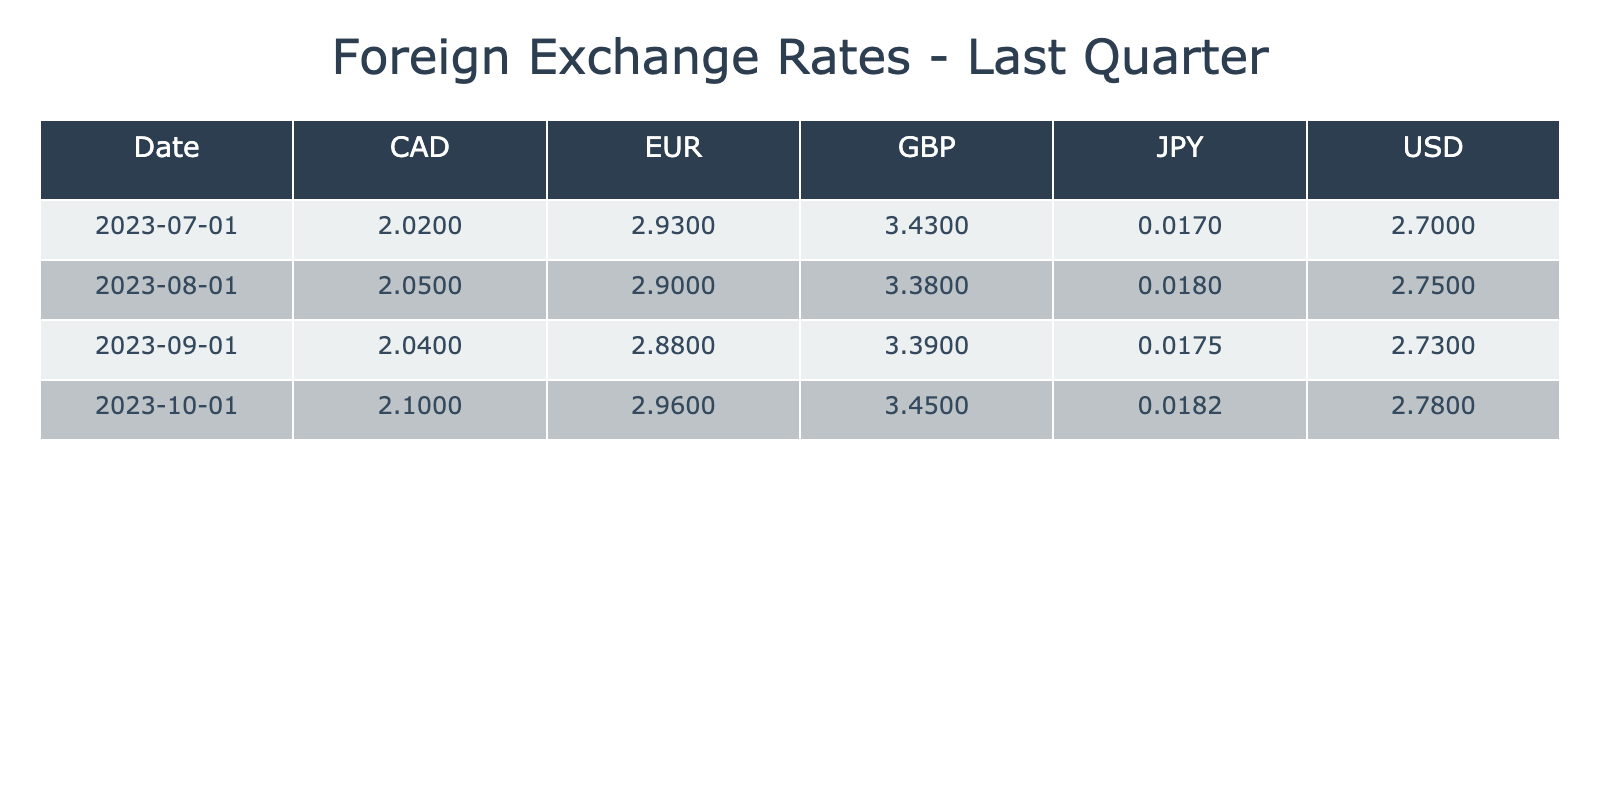What was the exchange rate for USD on July 1, 2023? According to the table, the exchange rate for USD on July 1, 2023, is listed directly in the corresponding cell.
Answer: 2.70 What was the highest exchange rate recorded for GBP during the last quarter? By reviewing the rows for GBP across the dates, the highest exchange rate is on October 1, 2023, where it is listed as 3.45.
Answer: 3.45 Was the exchange rate for EUR higher in August or September 2023? Comparing the EUR exchange rates for August (2.90) and September (2.88), it's clear that August has the higher rate.
Answer: August What is the average exchange rate for CAD over the last quarter? The exchange rates for CAD are 2.02, 2.05, 2.04, and 2.10. First, we sum these values: (2.02 + 2.05 + 2.04 + 2.10) = 8.21. We then divide by the number of months (4): 8.21 / 4 = 2.0525.
Answer: 2.05 Is the exchange rate for JPY consistent throughout the quarter? Reviewing the JPY exchange rates across the months reveals that it has changed: July (0.017), August (0.018), September (0.0175), and October (0.0182). Since these values vary, the exchange rate is not consistent.
Answer: No What was the percentage increase in the USD exchange rate from July to October 2023? To calculate the percentage increase, we use the formula ((new value - old value) / old value) * 100. The values are 2.70 in July and 2.78 in October. Thus, ((2.78 - 2.70) / 2.70) * 100 = (0.08 / 2.70) * 100 ≈ 2.96%.
Answer: 2.96% Which currency had the lowest exchange rate on September 1, 2023? By examining the exchange rates for all currencies on September 1, the lowest is for JPY at 0.0175, while USD, EUR, GBP, and CAD are all higher.
Answer: JPY How does the exchange rate for CAD compare to that of EUR on October 1, 2023? On October 1, 2023, CAD is at 2.10 and EUR is at 2.96. Thus, EUR has a higher exchange rate than CAD on that date.
Answer: EUR is higher When was the exchange rate for GBP the lowest during the quarter? Looking at the GBP rates: July (3.43), August (3.38), September (3.39), and October (3.45), the lowest is on August 1, 2023, at 3.38.
Answer: August 1, 2023 What is the difference between the highest and lowest exchange rates for USD observed? The highest USD exchange rate in the quarter is 2.78 in October and the lowest is 2.70 in July. The difference is calculated as: 2.78 - 2.70 = 0.08.
Answer: 0.08 Are there any months where the GBP value decreased? Reviewing the GBP rates: July (3.43), August (3.38), September (3.39), and October (3.45), we see that it decreased from July to August. Thus, there are months with a decrease in GBP value.
Answer: Yes 